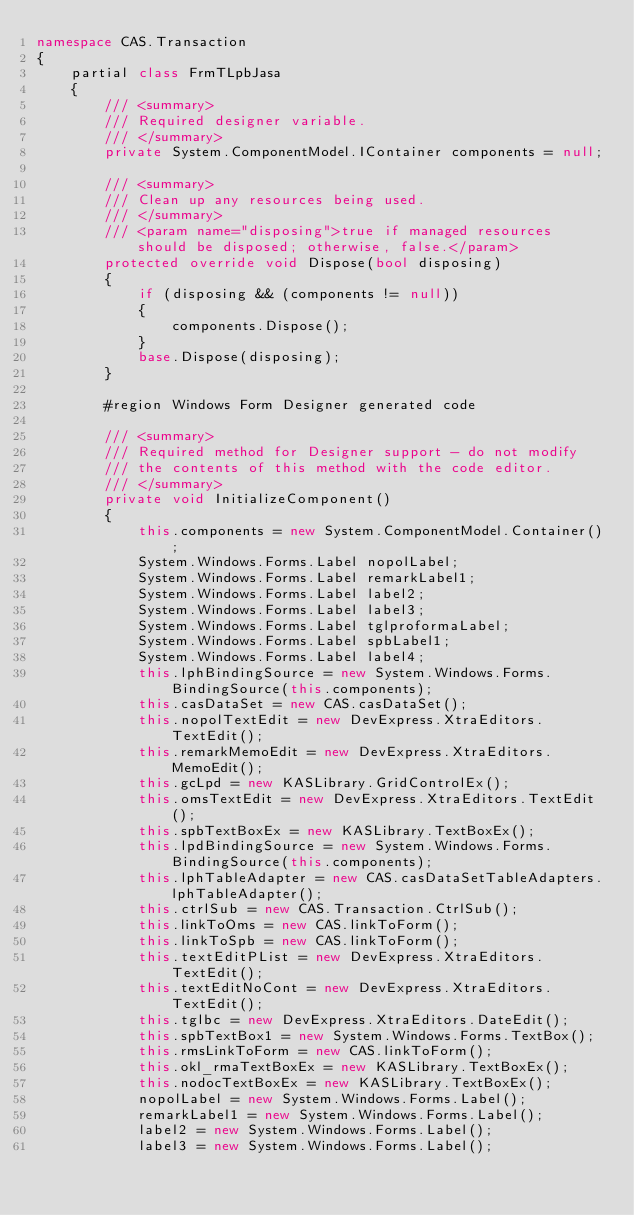<code> <loc_0><loc_0><loc_500><loc_500><_C#_>namespace CAS.Transaction
{
    partial class FrmTLpbJasa
    {
        /// <summary>
        /// Required designer variable.
        /// </summary>
        private System.ComponentModel.IContainer components = null;

        /// <summary>
        /// Clean up any resources being used.
        /// </summary>
        /// <param name="disposing">true if managed resources should be disposed; otherwise, false.</param>
        protected override void Dispose(bool disposing)
        {
            if (disposing && (components != null))
            {
                components.Dispose();
            }
            base.Dispose(disposing);
        }

        #region Windows Form Designer generated code

        /// <summary>
        /// Required method for Designer support - do not modify
        /// the contents of this method with the code editor.
        /// </summary>
        private void InitializeComponent()
        {
            this.components = new System.ComponentModel.Container();
            System.Windows.Forms.Label nopolLabel;
            System.Windows.Forms.Label remarkLabel1;
            System.Windows.Forms.Label label2;
            System.Windows.Forms.Label label3;
            System.Windows.Forms.Label tglproformaLabel;
            System.Windows.Forms.Label spbLabel1;
            System.Windows.Forms.Label label4;
            this.lphBindingSource = new System.Windows.Forms.BindingSource(this.components);
            this.casDataSet = new CAS.casDataSet();
            this.nopolTextEdit = new DevExpress.XtraEditors.TextEdit();
            this.remarkMemoEdit = new DevExpress.XtraEditors.MemoEdit();
            this.gcLpd = new KASLibrary.GridControlEx();
            this.omsTextEdit = new DevExpress.XtraEditors.TextEdit();
            this.spbTextBoxEx = new KASLibrary.TextBoxEx();
            this.lpdBindingSource = new System.Windows.Forms.BindingSource(this.components);
            this.lphTableAdapter = new CAS.casDataSetTableAdapters.lphTableAdapter();
            this.ctrlSub = new CAS.Transaction.CtrlSub();
            this.linkToOms = new CAS.linkToForm();
            this.linkToSpb = new CAS.linkToForm();
            this.textEditPList = new DevExpress.XtraEditors.TextEdit();
            this.textEditNoCont = new DevExpress.XtraEditors.TextEdit();
            this.tglbc = new DevExpress.XtraEditors.DateEdit();
            this.spbTextBox1 = new System.Windows.Forms.TextBox();
            this.rmsLinkToForm = new CAS.linkToForm();
            this.okl_rmaTextBoxEx = new KASLibrary.TextBoxEx();
            this.nodocTextBoxEx = new KASLibrary.TextBoxEx();
            nopolLabel = new System.Windows.Forms.Label();
            remarkLabel1 = new System.Windows.Forms.Label();
            label2 = new System.Windows.Forms.Label();
            label3 = new System.Windows.Forms.Label();</code> 